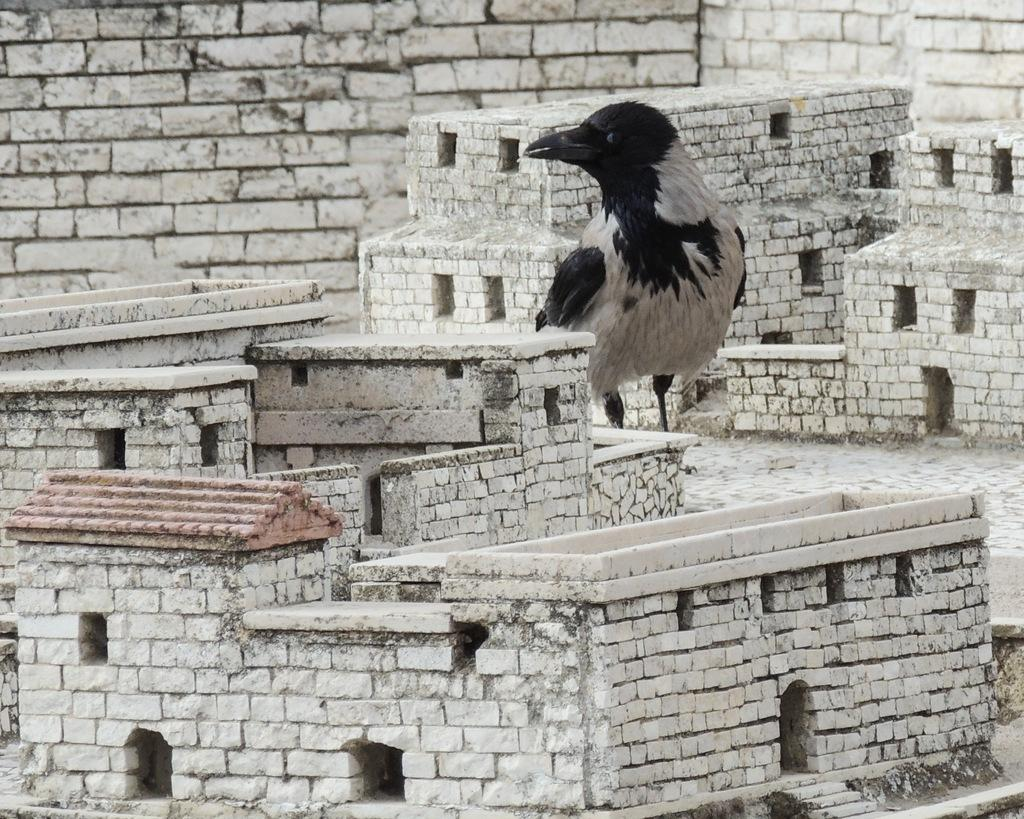What type of structures are depicted in the image? There are small houses in the image. What type of animal can be seen in the image? There is a bird in the image. What can be seen in the background of the image? There is a brick wall in the background of the image. What news story is the bird reporting on in the image? There is no indication in the image that the bird is reporting on any news story. 